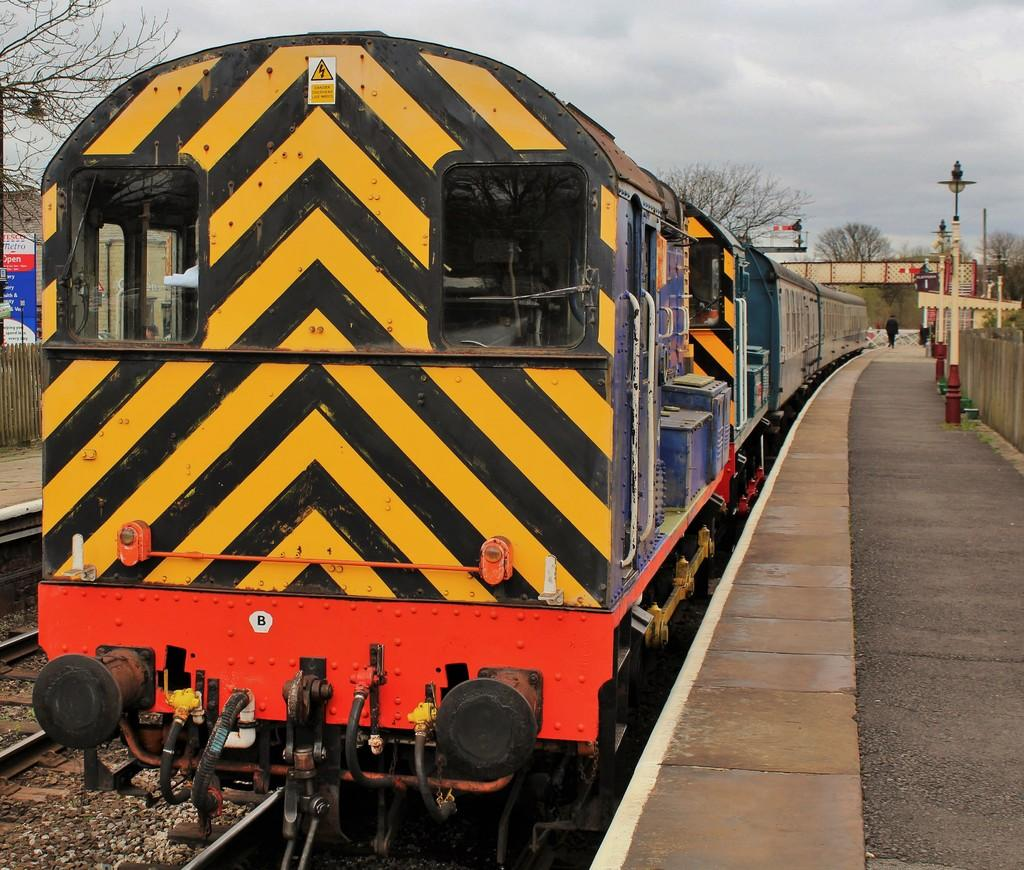What is the main subject of the image? The main subject of the image is a train. What can be seen alongside the train in the image? There are railway tracks and a platform in the image. What other objects or features can be seen in the image? There are trees, light poles, a board with text, houses, and the sky visible in the image. What type of legal advice is the lawyer providing on the elbow in the image? There is no lawyer or elbow present in the image. What feeling does the image evoke in the viewer? The image itself does not evoke a specific feeling, as feelings are subjective and cannot be definitively determined from the image alone. 